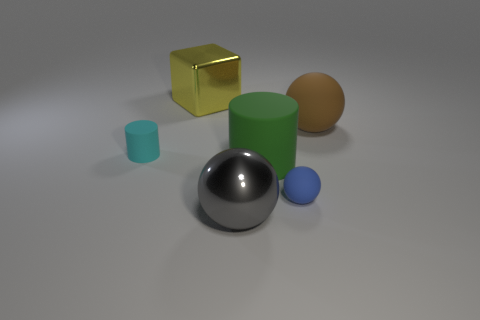What size is the blue object that is the same shape as the big gray metal thing?
Keep it short and to the point. Small. There is a metallic thing that is behind the large brown matte object; what is its shape?
Provide a short and direct response. Cube. Are there fewer big cyan rubber balls than small blue matte objects?
Keep it short and to the point. Yes. Is the material of the big object that is right of the small blue thing the same as the large gray sphere?
Ensure brevity in your answer.  No. There is a tiny cyan thing; are there any green cylinders on the right side of it?
Your answer should be very brief. Yes. What is the color of the ball that is right of the tiny object on the right side of the matte thing that is left of the large yellow metallic block?
Your response must be concise. Brown. There is a yellow metal thing that is the same size as the gray metal sphere; what is its shape?
Your answer should be very brief. Cube. Are there more big red metallic cubes than large green cylinders?
Provide a short and direct response. No. There is a large shiny object that is behind the big metallic ball; are there any large yellow metal blocks that are left of it?
Your response must be concise. No. What is the color of the other small rubber object that is the same shape as the green object?
Make the answer very short. Cyan. 